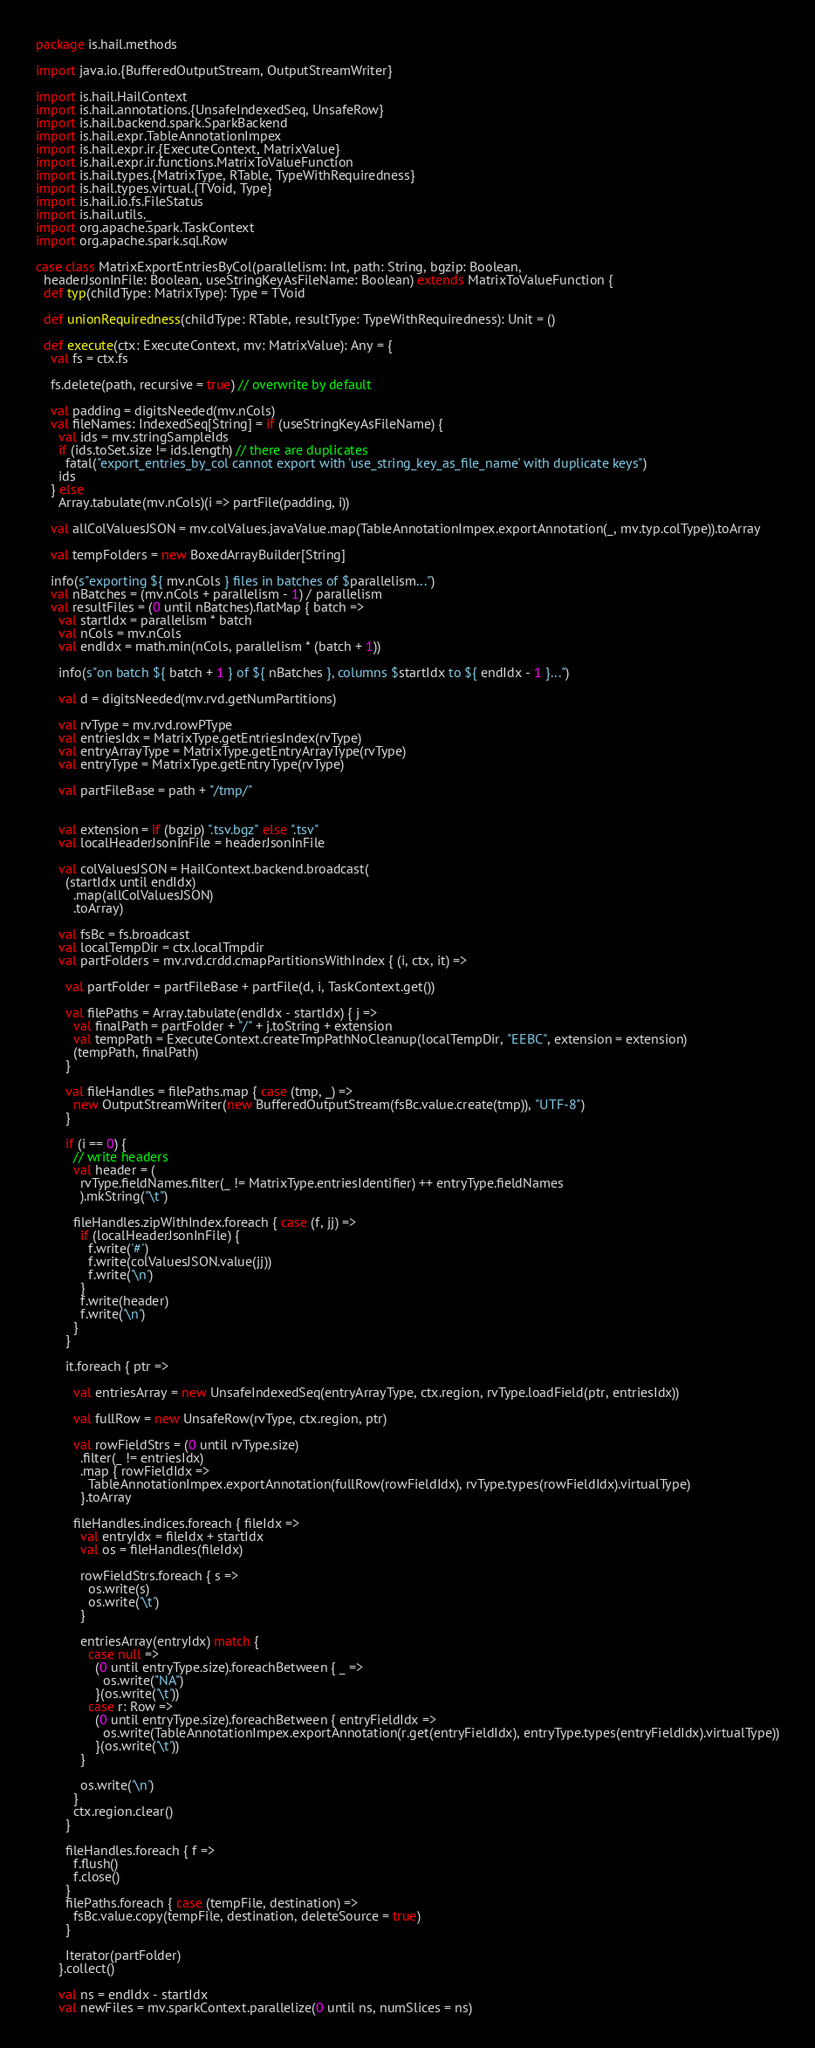Convert code to text. <code><loc_0><loc_0><loc_500><loc_500><_Scala_>package is.hail.methods

import java.io.{BufferedOutputStream, OutputStreamWriter}

import is.hail.HailContext
import is.hail.annotations.{UnsafeIndexedSeq, UnsafeRow}
import is.hail.backend.spark.SparkBackend
import is.hail.expr.TableAnnotationImpex
import is.hail.expr.ir.{ExecuteContext, MatrixValue}
import is.hail.expr.ir.functions.MatrixToValueFunction
import is.hail.types.{MatrixType, RTable, TypeWithRequiredness}
import is.hail.types.virtual.{TVoid, Type}
import is.hail.io.fs.FileStatus
import is.hail.utils._
import org.apache.spark.TaskContext
import org.apache.spark.sql.Row

case class MatrixExportEntriesByCol(parallelism: Int, path: String, bgzip: Boolean,
  headerJsonInFile: Boolean, useStringKeyAsFileName: Boolean) extends MatrixToValueFunction {
  def typ(childType: MatrixType): Type = TVoid

  def unionRequiredness(childType: RTable, resultType: TypeWithRequiredness): Unit = ()

  def execute(ctx: ExecuteContext, mv: MatrixValue): Any = {
    val fs = ctx.fs

    fs.delete(path, recursive = true) // overwrite by default

    val padding = digitsNeeded(mv.nCols)
    val fileNames: IndexedSeq[String] = if (useStringKeyAsFileName) {
      val ids = mv.stringSampleIds
      if (ids.toSet.size != ids.length) // there are duplicates
        fatal("export_entries_by_col cannot export with 'use_string_key_as_file_name' with duplicate keys")
      ids
    } else
      Array.tabulate(mv.nCols)(i => partFile(padding, i))

    val allColValuesJSON = mv.colValues.javaValue.map(TableAnnotationImpex.exportAnnotation(_, mv.typ.colType)).toArray

    val tempFolders = new BoxedArrayBuilder[String]

    info(s"exporting ${ mv.nCols } files in batches of $parallelism...")
    val nBatches = (mv.nCols + parallelism - 1) / parallelism
    val resultFiles = (0 until nBatches).flatMap { batch =>
      val startIdx = parallelism * batch
      val nCols = mv.nCols
      val endIdx = math.min(nCols, parallelism * (batch + 1))

      info(s"on batch ${ batch + 1 } of ${ nBatches }, columns $startIdx to ${ endIdx - 1 }...")

      val d = digitsNeeded(mv.rvd.getNumPartitions)

      val rvType = mv.rvd.rowPType
      val entriesIdx = MatrixType.getEntriesIndex(rvType)
      val entryArrayType = MatrixType.getEntryArrayType(rvType)
      val entryType = MatrixType.getEntryType(rvType)

      val partFileBase = path + "/tmp/"


      val extension = if (bgzip) ".tsv.bgz" else ".tsv"
      val localHeaderJsonInFile = headerJsonInFile

      val colValuesJSON = HailContext.backend.broadcast(
        (startIdx until endIdx)
          .map(allColValuesJSON)
          .toArray)

      val fsBc = fs.broadcast
      val localTempDir = ctx.localTmpdir
      val partFolders = mv.rvd.crdd.cmapPartitionsWithIndex { (i, ctx, it) =>

        val partFolder = partFileBase + partFile(d, i, TaskContext.get())

        val filePaths = Array.tabulate(endIdx - startIdx) { j =>
          val finalPath = partFolder + "/" + j.toString + extension
          val tempPath = ExecuteContext.createTmpPathNoCleanup(localTempDir, "EEBC", extension = extension)
          (tempPath, finalPath)
        }

        val fileHandles = filePaths.map { case (tmp, _) =>
          new OutputStreamWriter(new BufferedOutputStream(fsBc.value.create(tmp)), "UTF-8")
        }

        if (i == 0) {
          // write headers
          val header = (
            rvType.fieldNames.filter(_ != MatrixType.entriesIdentifier) ++ entryType.fieldNames
            ).mkString("\t")

          fileHandles.zipWithIndex.foreach { case (f, jj) =>
            if (localHeaderJsonInFile) {
              f.write('#')
              f.write(colValuesJSON.value(jj))
              f.write('\n')
            }
            f.write(header)
            f.write('\n')
          }
        }

        it.foreach { ptr =>

          val entriesArray = new UnsafeIndexedSeq(entryArrayType, ctx.region, rvType.loadField(ptr, entriesIdx))

          val fullRow = new UnsafeRow(rvType, ctx.region, ptr)

          val rowFieldStrs = (0 until rvType.size)
            .filter(_ != entriesIdx)
            .map { rowFieldIdx =>
              TableAnnotationImpex.exportAnnotation(fullRow(rowFieldIdx), rvType.types(rowFieldIdx).virtualType)
            }.toArray

          fileHandles.indices.foreach { fileIdx =>
            val entryIdx = fileIdx + startIdx
            val os = fileHandles(fileIdx)

            rowFieldStrs.foreach { s =>
              os.write(s)
              os.write('\t')
            }

            entriesArray(entryIdx) match {
              case null =>
                (0 until entryType.size).foreachBetween { _ =>
                  os.write("NA")
                }(os.write('\t'))
              case r: Row =>
                (0 until entryType.size).foreachBetween { entryFieldIdx =>
                  os.write(TableAnnotationImpex.exportAnnotation(r.get(entryFieldIdx), entryType.types(entryFieldIdx).virtualType))
                }(os.write('\t'))
            }

            os.write('\n')
          }
          ctx.region.clear()
        }

        fileHandles.foreach { f =>
          f.flush()
          f.close()
        }
        filePaths.foreach { case (tempFile, destination) =>
          fsBc.value.copy(tempFile, destination, deleteSource = true)
        }

        Iterator(partFolder)
      }.collect()

      val ns = endIdx - startIdx
      val newFiles = mv.sparkContext.parallelize(0 until ns, numSlices = ns)</code> 